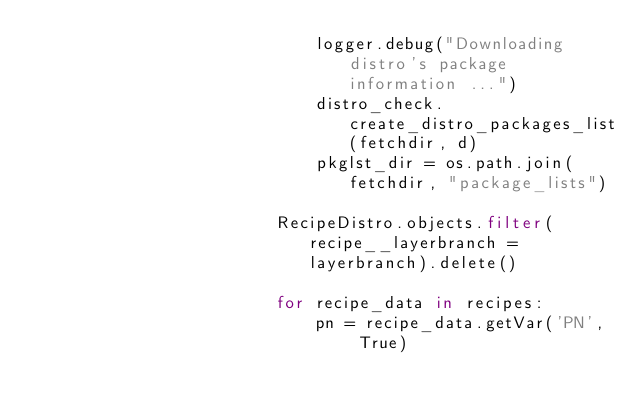Convert code to text. <code><loc_0><loc_0><loc_500><loc_500><_Python_>                            logger.debug("Downloading distro's package information ...")
                            distro_check.create_distro_packages_list(fetchdir, d)
                            pkglst_dir = os.path.join(fetchdir, "package_lists")

                        RecipeDistro.objects.filter(recipe__layerbranch = layerbranch).delete()

                        for recipe_data in recipes:
                            pn = recipe_data.getVar('PN', True)</code> 